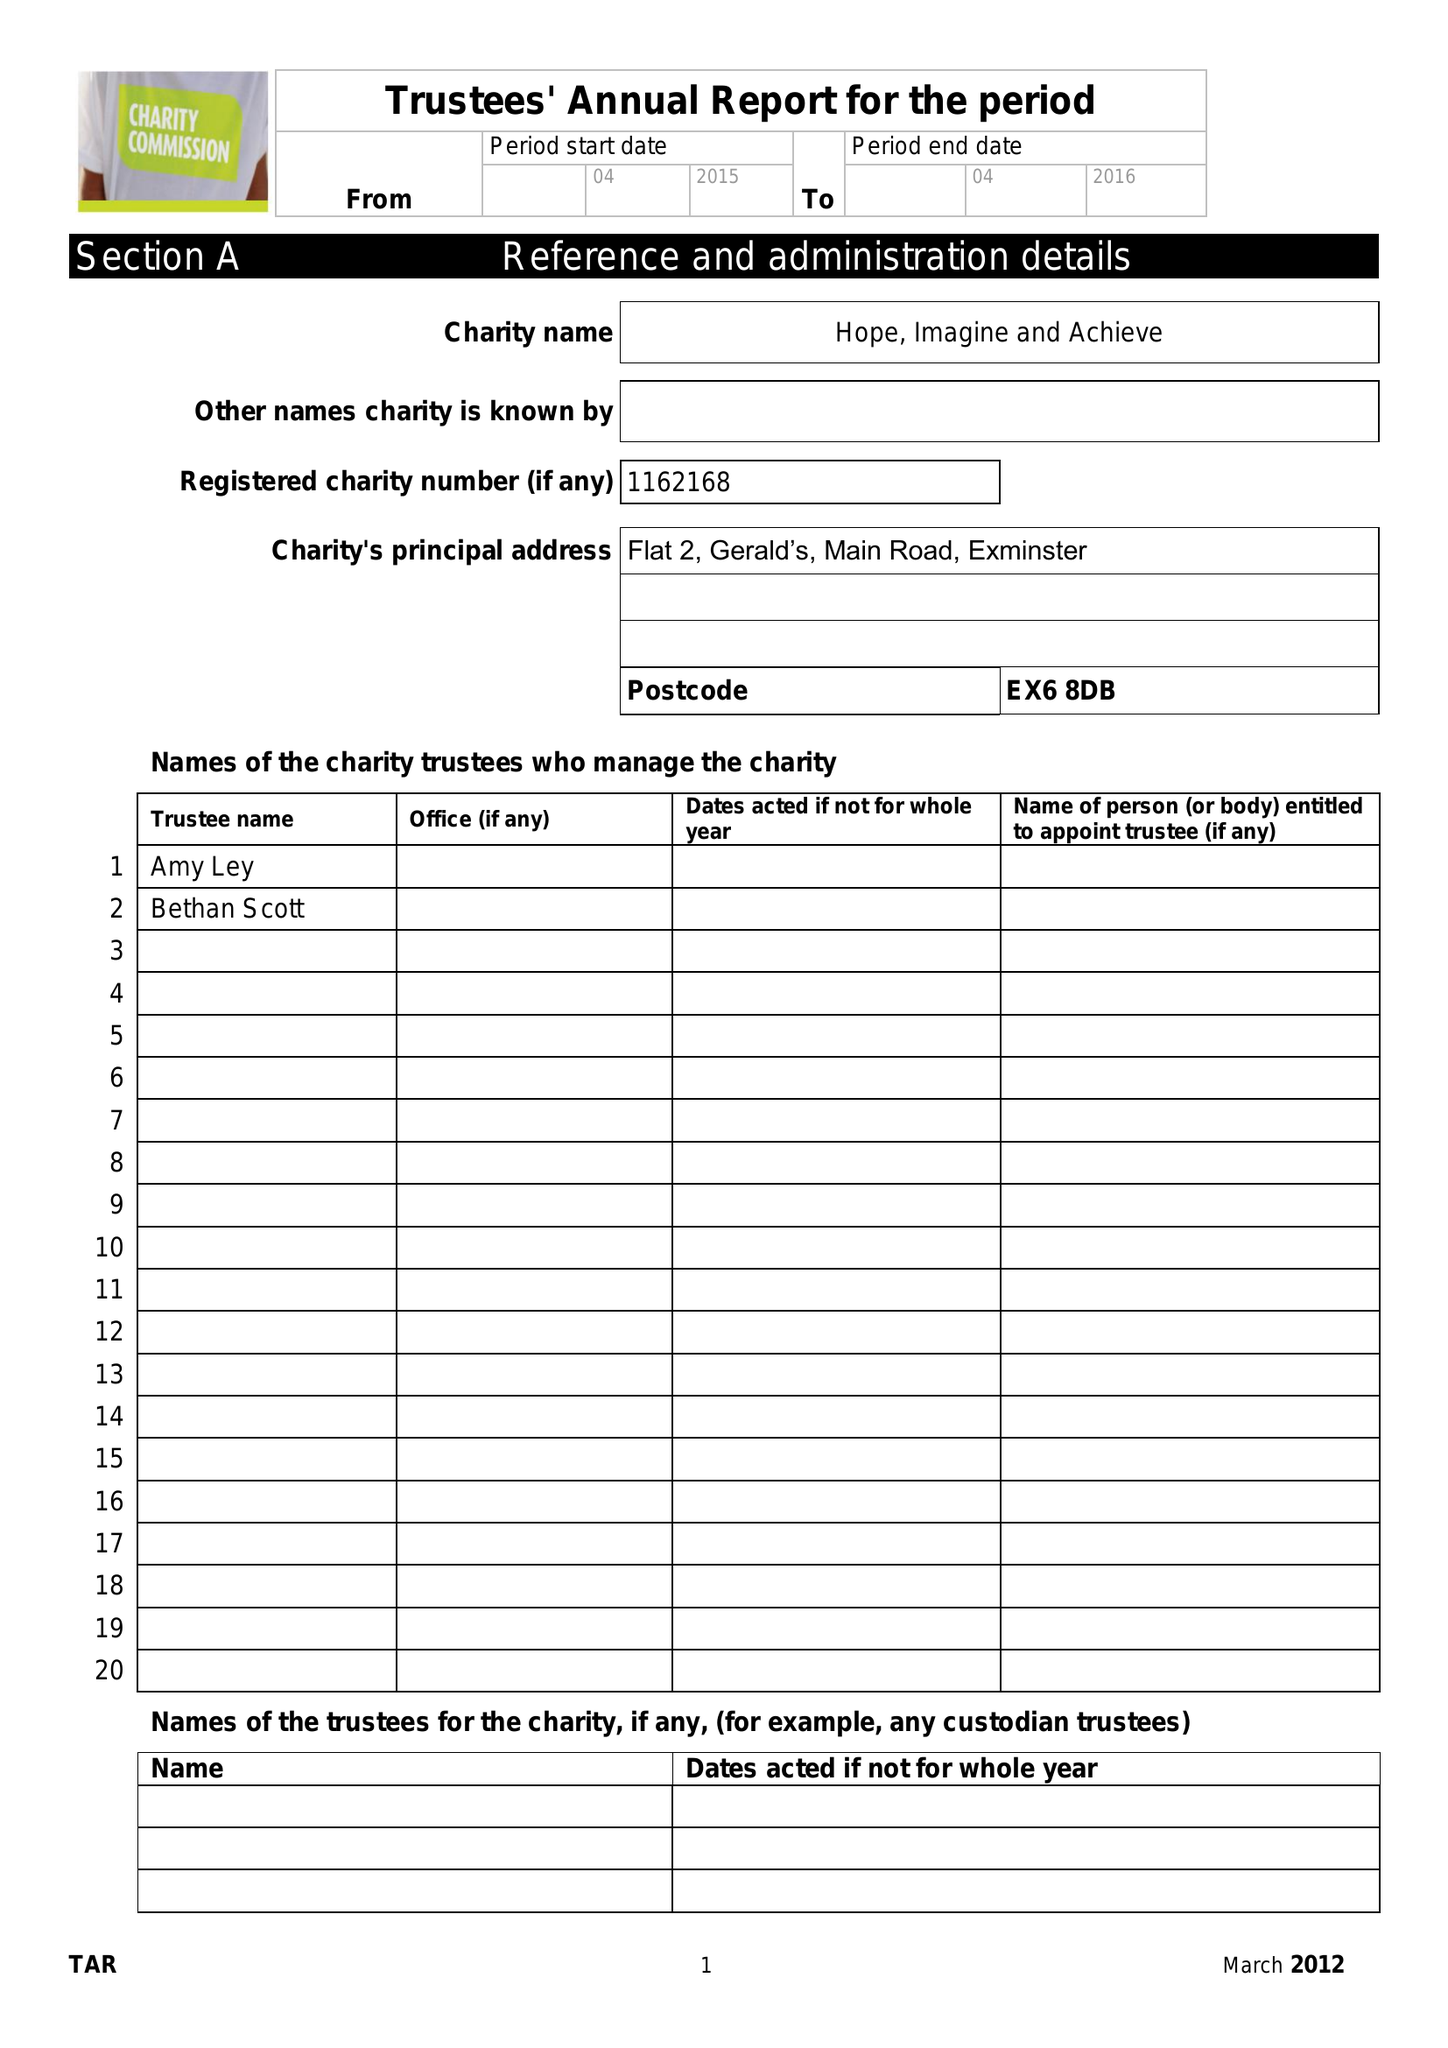What is the value for the charity_name?
Answer the question using a single word or phrase. Hope, Imagine and Achieve 